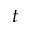<formula> <loc_0><loc_0><loc_500><loc_500>t</formula> 